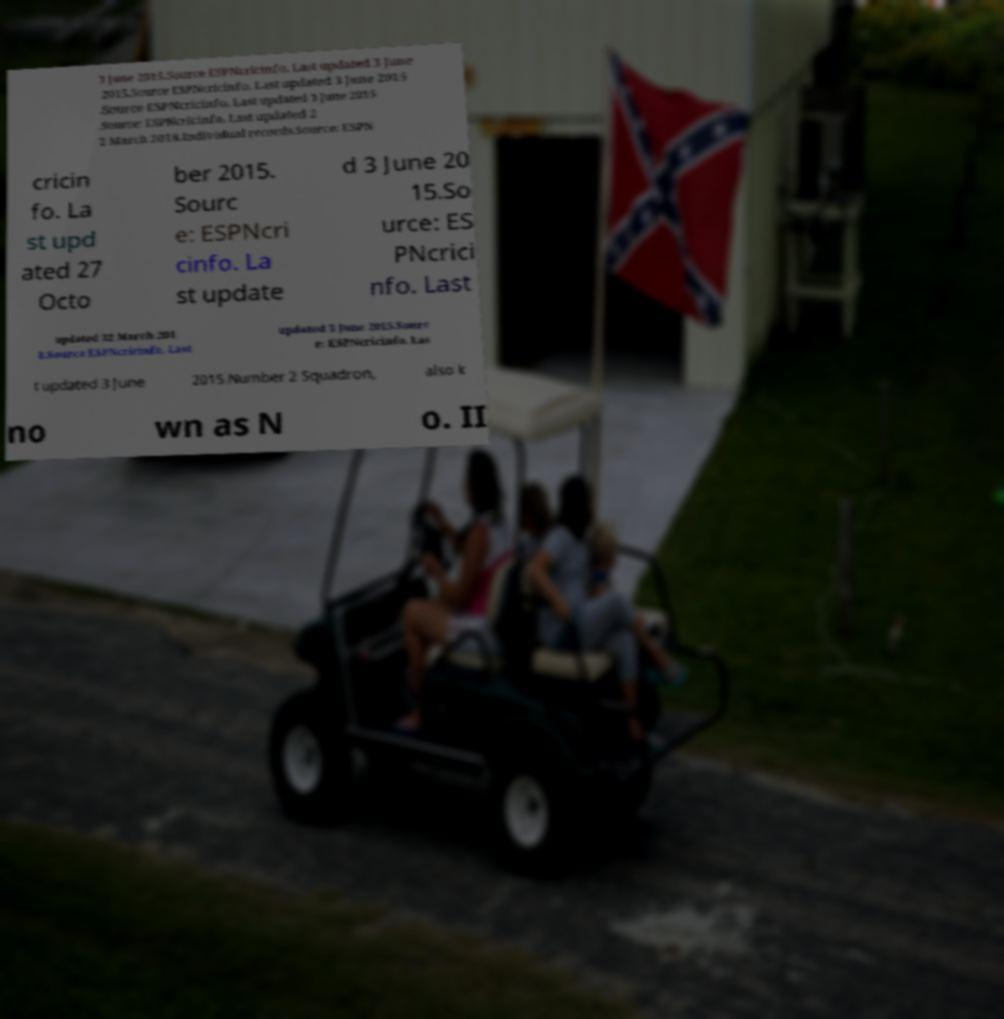What messages or text are displayed in this image? I need them in a readable, typed format. 3 June 2015.Source ESPNcricinfo. Last updated 3 June 2015.Source ESPNcricinfo. Last updated 3 June 2015 .Source ESPNcricinfo. Last updated 3 June 2015 .Source: ESPNcricinfo. Last updated 2 2 March 2018.Individual records.Source: ESPN cricin fo. La st upd ated 27 Octo ber 2015. Sourc e: ESPNcri cinfo. La st update d 3 June 20 15.So urce: ES PNcrici nfo. Last updated 22 March 201 8.Source ESPNcricinfo. Last updated 3 June 2015.Sourc e: ESPNcricinfo. Las t updated 3 June 2015.Number 2 Squadron, also k no wn as N o. II 